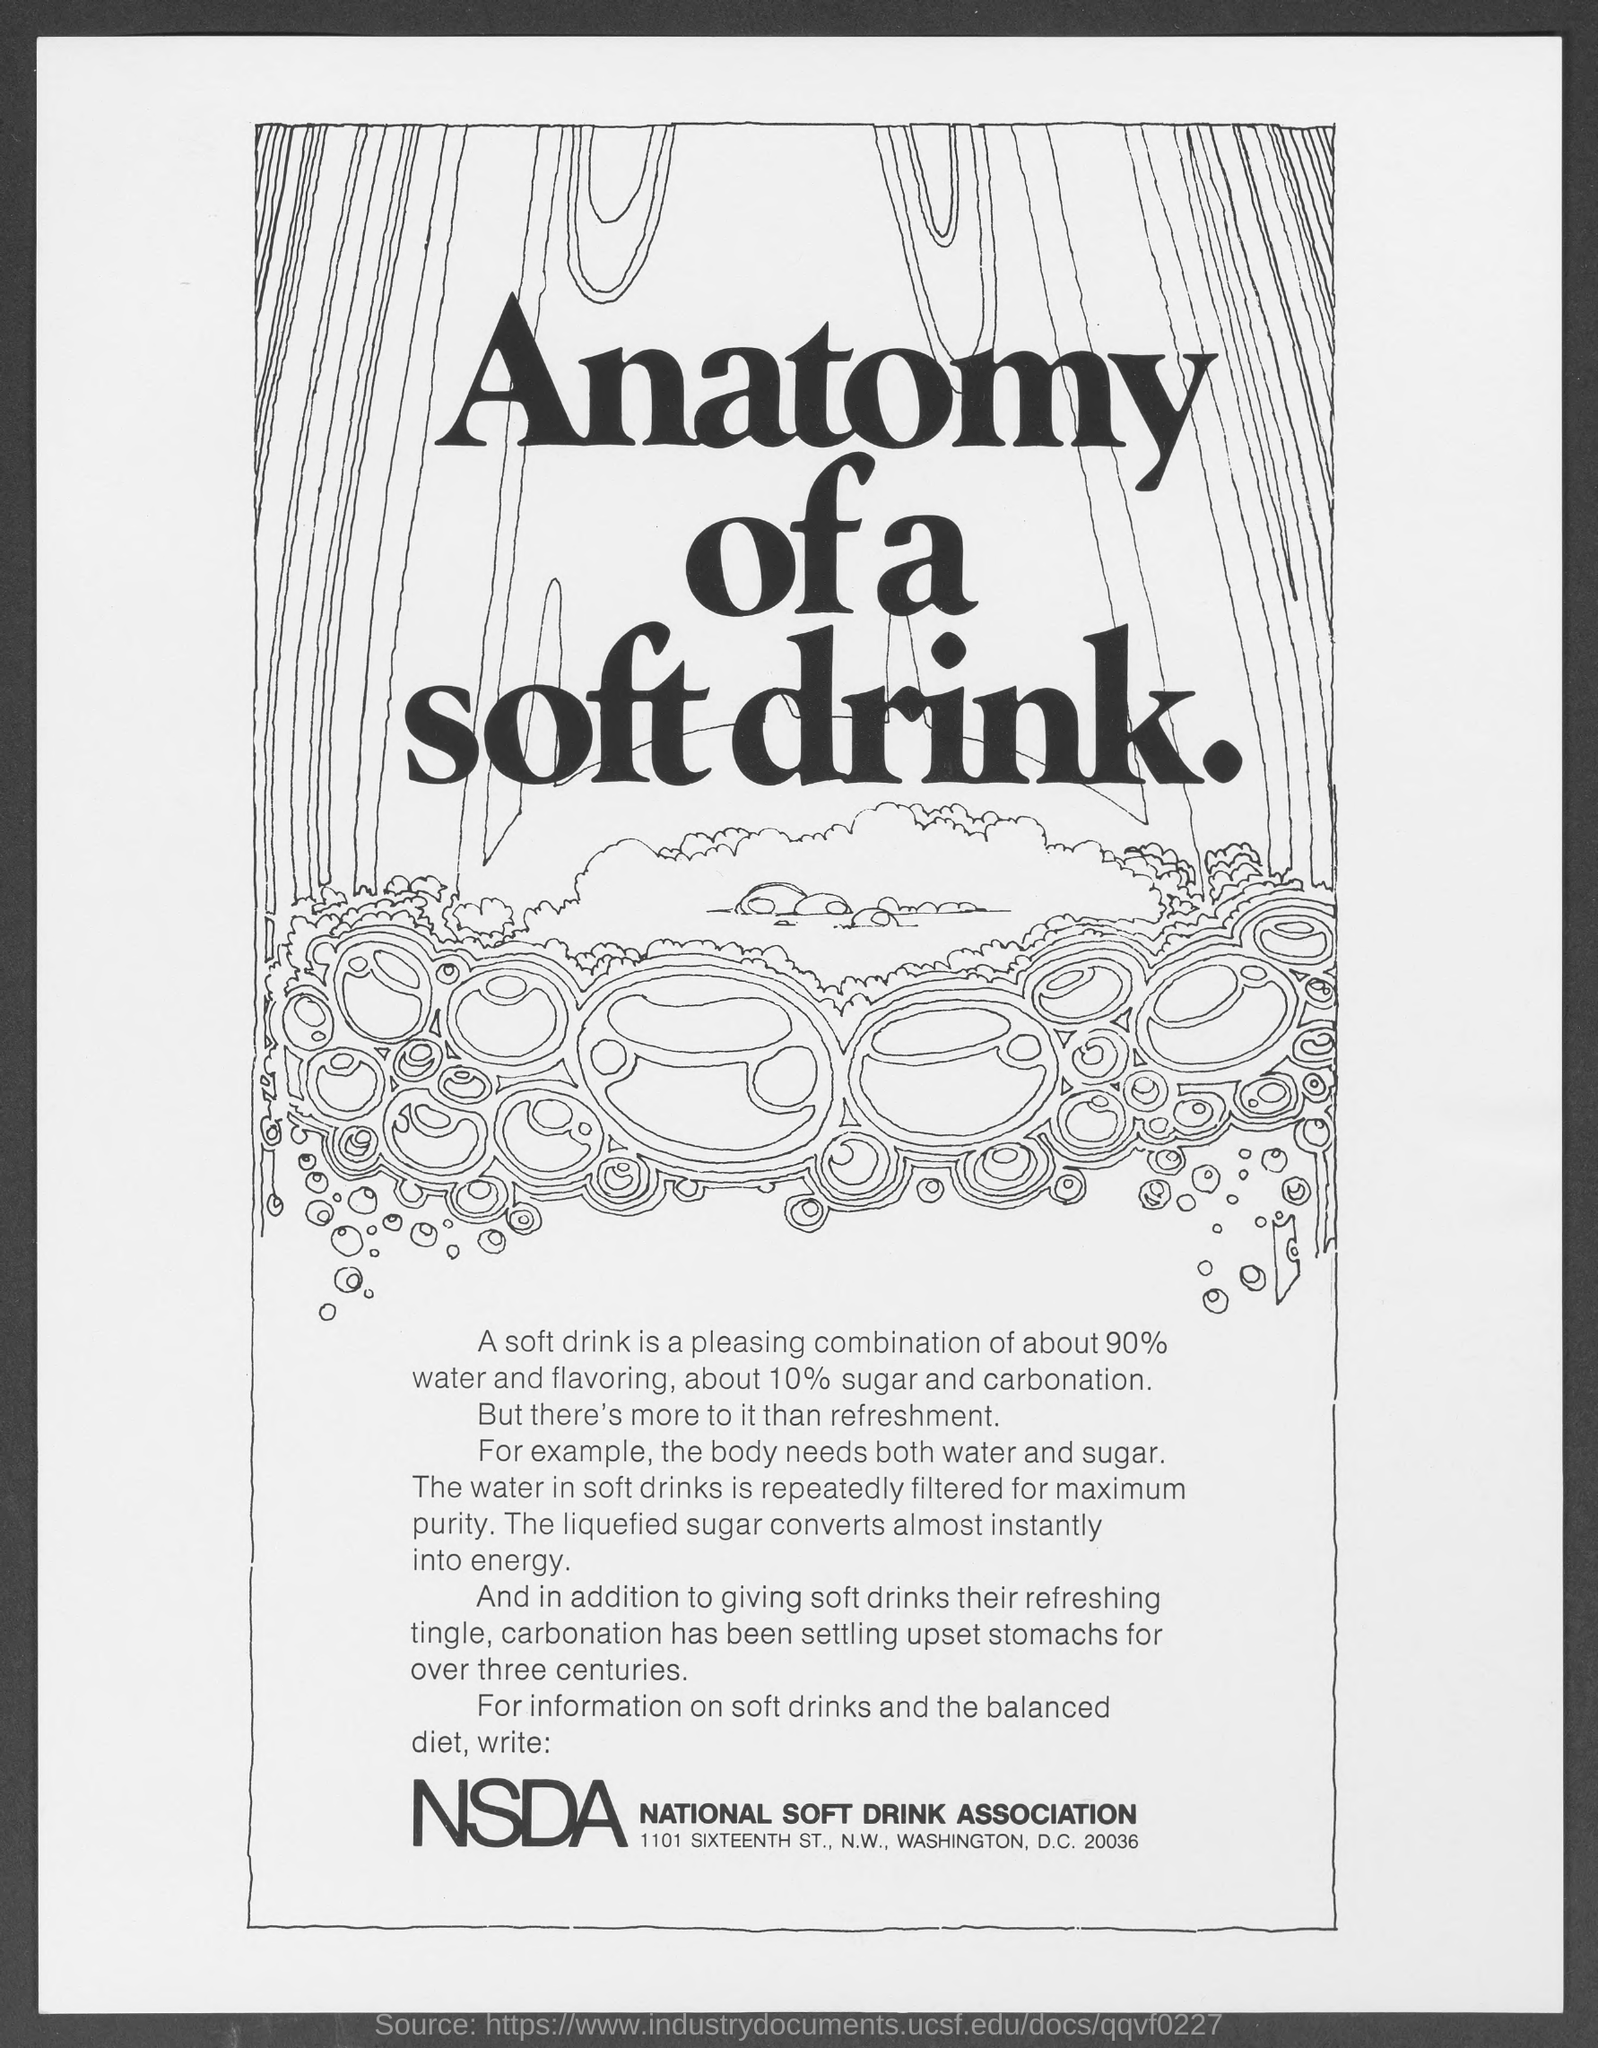Give some essential details in this illustration. National Council on Drug Abuse (NCDA) is an organization dedicated to promoting drug-free living and preventing drug abuse. 